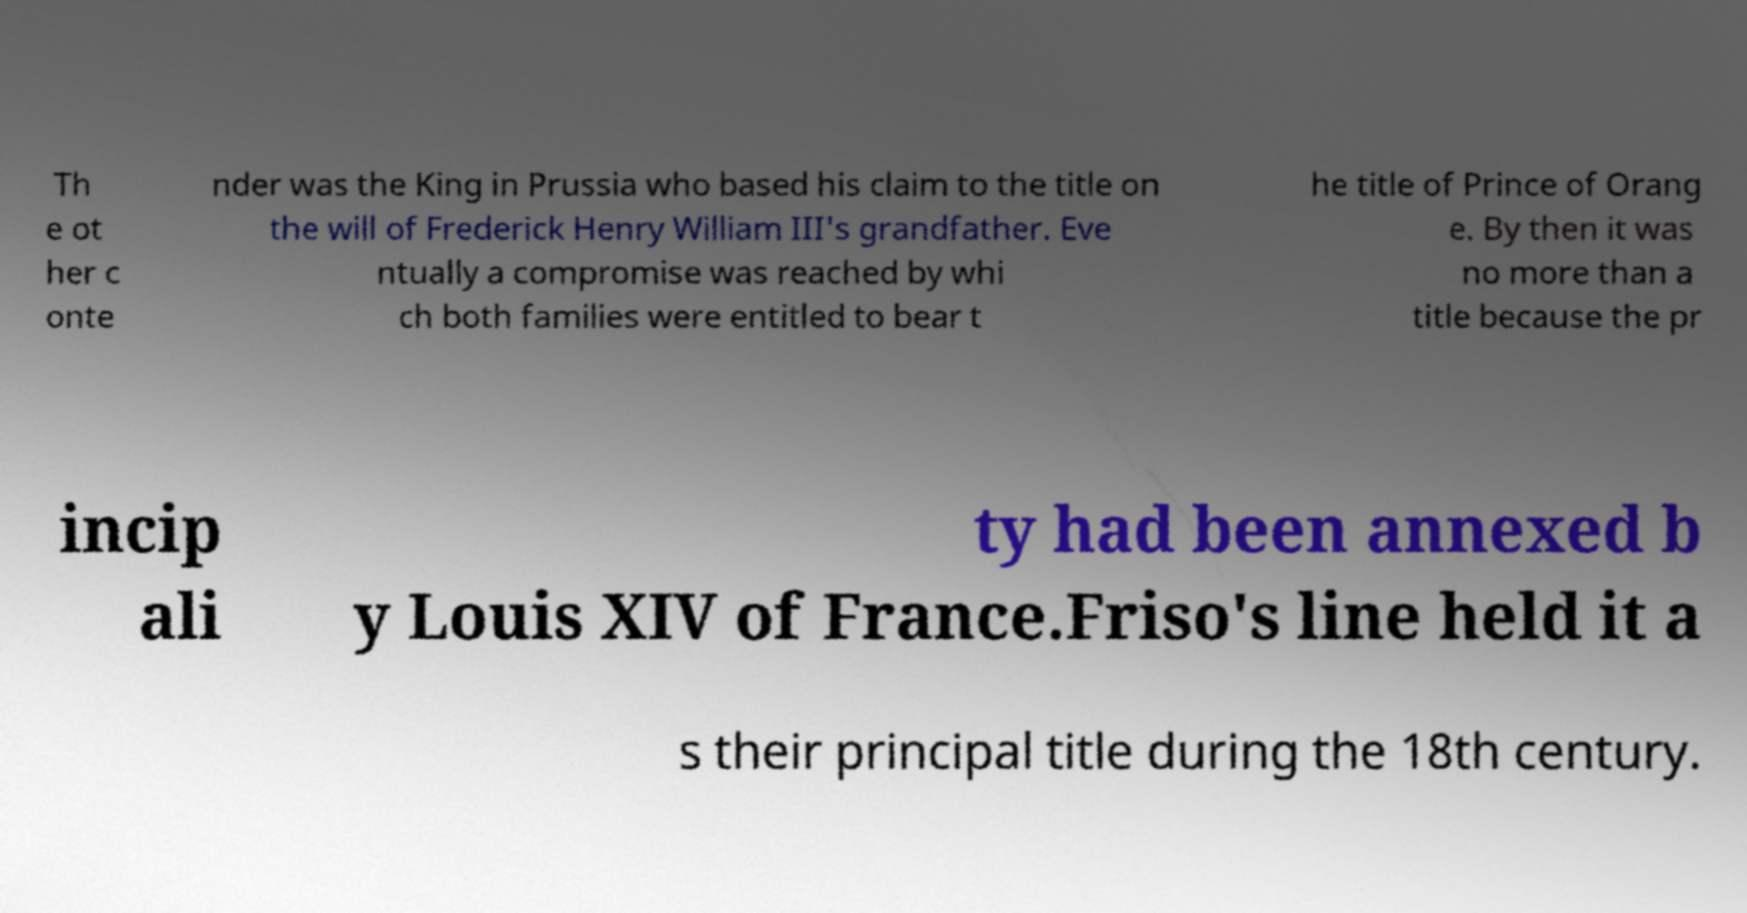For documentation purposes, I need the text within this image transcribed. Could you provide that? Th e ot her c onte nder was the King in Prussia who based his claim to the title on the will of Frederick Henry William III's grandfather. Eve ntually a compromise was reached by whi ch both families were entitled to bear t he title of Prince of Orang e. By then it was no more than a title because the pr incip ali ty had been annexed b y Louis XIV of France.Friso's line held it a s their principal title during the 18th century. 